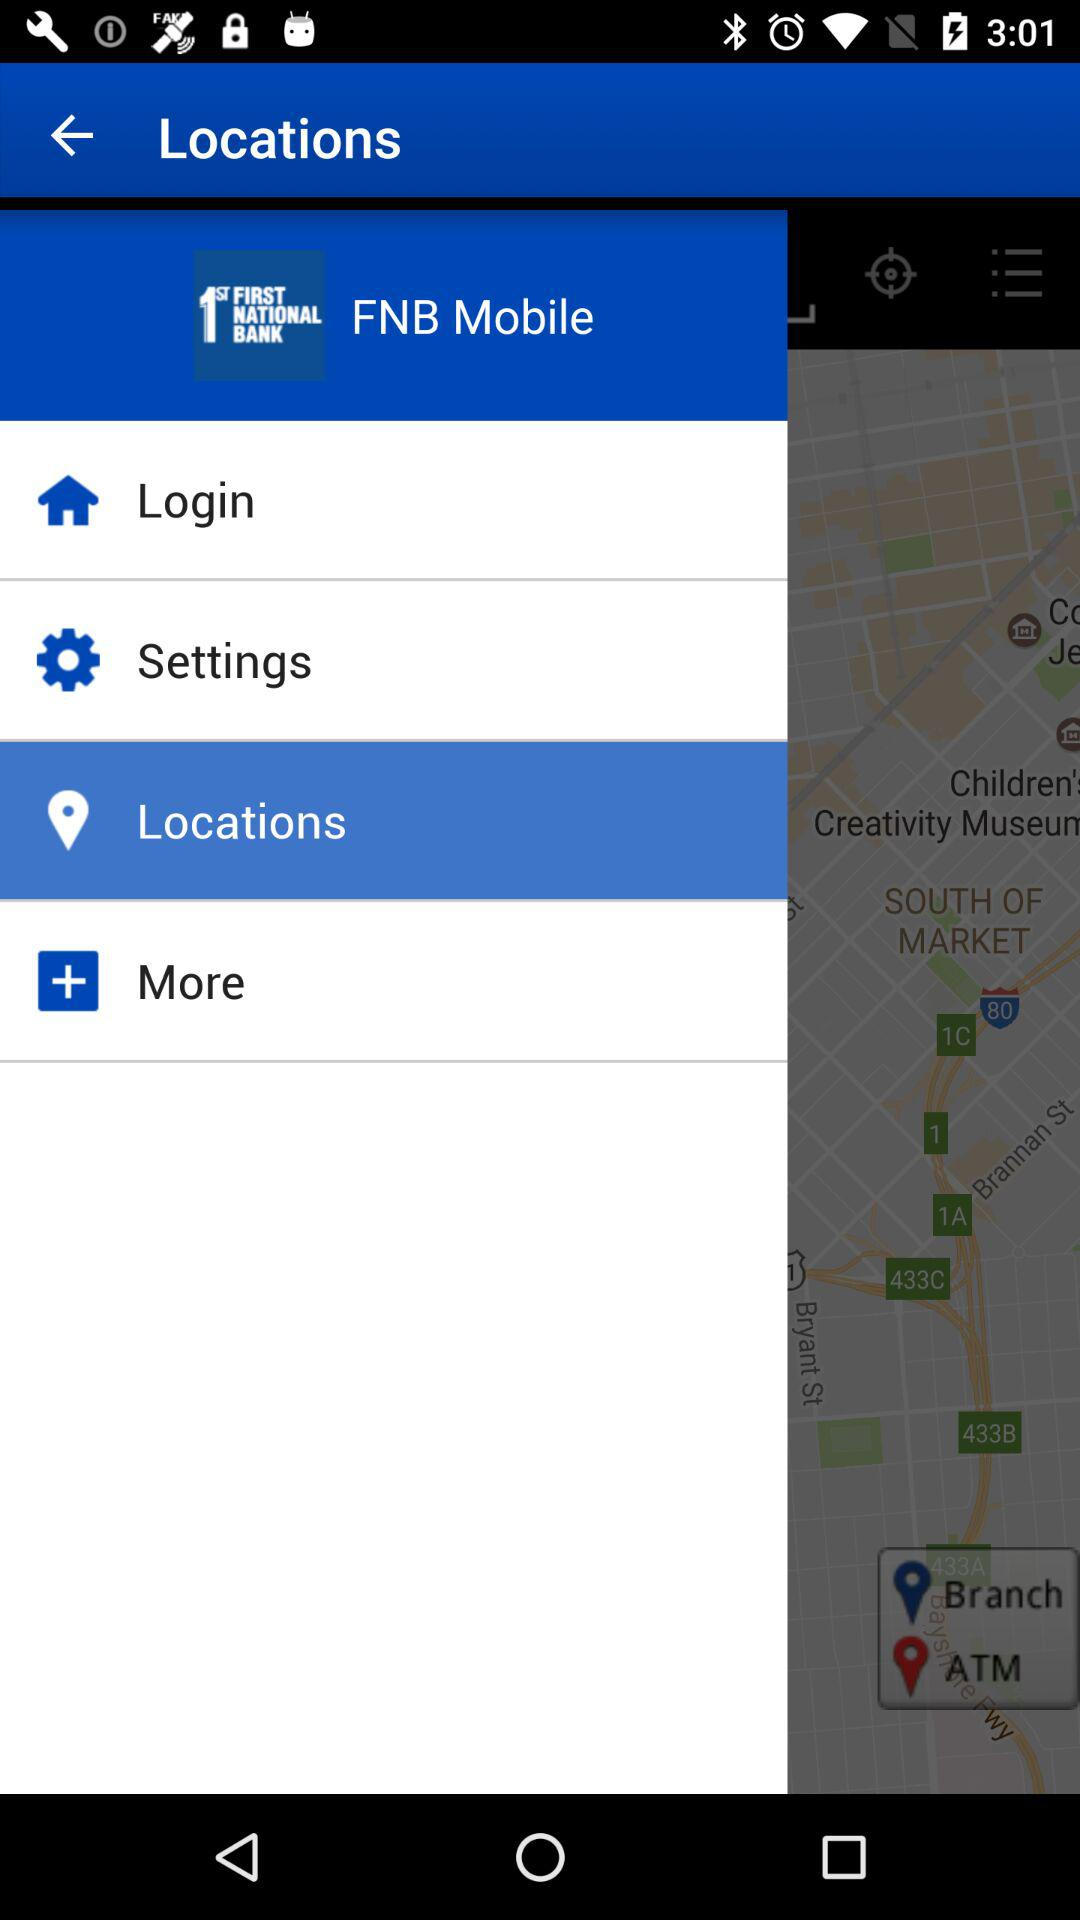What is the selected tab in the menu? The selected tab in the menu is "Locations". 